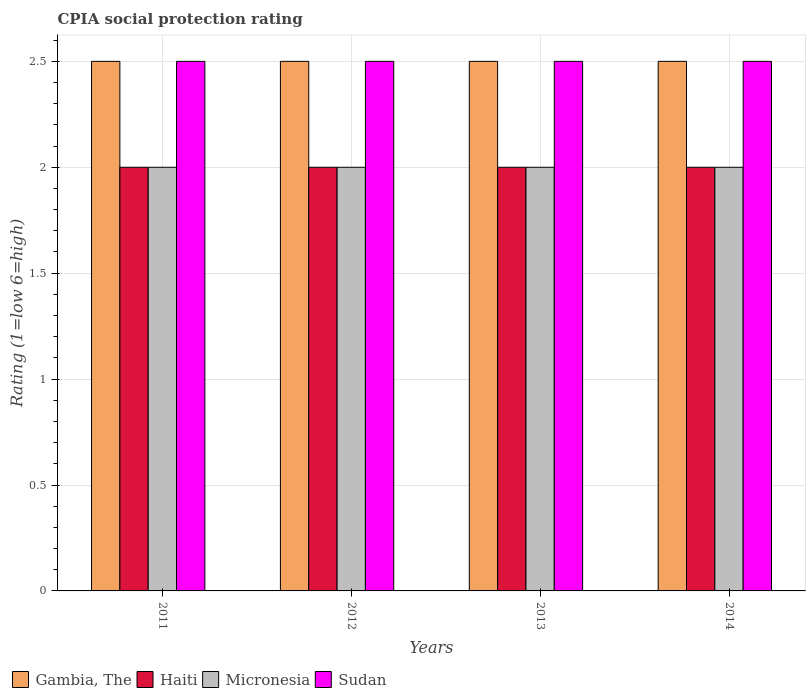How many groups of bars are there?
Provide a short and direct response. 4. Are the number of bars per tick equal to the number of legend labels?
Provide a succinct answer. Yes. How many bars are there on the 4th tick from the left?
Give a very brief answer. 4. How many bars are there on the 4th tick from the right?
Make the answer very short. 4. What is the label of the 2nd group of bars from the left?
Offer a very short reply. 2012. In how many cases, is the number of bars for a given year not equal to the number of legend labels?
Provide a succinct answer. 0. What is the CPIA rating in Sudan in 2012?
Ensure brevity in your answer.  2.5. Across all years, what is the maximum CPIA rating in Gambia, The?
Ensure brevity in your answer.  2.5. Across all years, what is the minimum CPIA rating in Micronesia?
Your answer should be very brief. 2. In which year was the CPIA rating in Sudan maximum?
Offer a very short reply. 2011. What is the total CPIA rating in Sudan in the graph?
Offer a very short reply. 10. What is the difference between the CPIA rating in Sudan in 2014 and the CPIA rating in Micronesia in 2013?
Provide a succinct answer. 0.5. What is the average CPIA rating in Gambia, The per year?
Provide a short and direct response. 2.5. In the year 2011, what is the difference between the CPIA rating in Sudan and CPIA rating in Haiti?
Ensure brevity in your answer.  0.5. Is the CPIA rating in Gambia, The in 2011 less than that in 2014?
Your response must be concise. No. In how many years, is the CPIA rating in Haiti greater than the average CPIA rating in Haiti taken over all years?
Ensure brevity in your answer.  0. Is the sum of the CPIA rating in Micronesia in 2011 and 2012 greater than the maximum CPIA rating in Haiti across all years?
Keep it short and to the point. Yes. Is it the case that in every year, the sum of the CPIA rating in Gambia, The and CPIA rating in Haiti is greater than the sum of CPIA rating in Sudan and CPIA rating in Micronesia?
Make the answer very short. Yes. What does the 3rd bar from the left in 2013 represents?
Your answer should be very brief. Micronesia. What does the 4th bar from the right in 2011 represents?
Your answer should be very brief. Gambia, The. Are the values on the major ticks of Y-axis written in scientific E-notation?
Your response must be concise. No. Does the graph contain any zero values?
Your answer should be compact. No. How are the legend labels stacked?
Keep it short and to the point. Horizontal. What is the title of the graph?
Your response must be concise. CPIA social protection rating. Does "Kuwait" appear as one of the legend labels in the graph?
Provide a short and direct response. No. What is the Rating (1=low 6=high) in Haiti in 2011?
Your response must be concise. 2. What is the Rating (1=low 6=high) in Gambia, The in 2012?
Keep it short and to the point. 2.5. What is the Rating (1=low 6=high) of Micronesia in 2012?
Your response must be concise. 2. What is the Rating (1=low 6=high) of Sudan in 2012?
Your response must be concise. 2.5. What is the Rating (1=low 6=high) in Gambia, The in 2013?
Provide a succinct answer. 2.5. What is the Rating (1=low 6=high) in Haiti in 2013?
Keep it short and to the point. 2. What is the Rating (1=low 6=high) in Micronesia in 2013?
Your answer should be very brief. 2. What is the Rating (1=low 6=high) in Sudan in 2013?
Make the answer very short. 2.5. What is the Rating (1=low 6=high) in Sudan in 2014?
Ensure brevity in your answer.  2.5. Across all years, what is the maximum Rating (1=low 6=high) in Gambia, The?
Provide a short and direct response. 2.5. Across all years, what is the maximum Rating (1=low 6=high) in Haiti?
Your answer should be compact. 2. Across all years, what is the maximum Rating (1=low 6=high) of Micronesia?
Provide a short and direct response. 2. Across all years, what is the maximum Rating (1=low 6=high) in Sudan?
Provide a short and direct response. 2.5. Across all years, what is the minimum Rating (1=low 6=high) in Haiti?
Offer a terse response. 2. Across all years, what is the minimum Rating (1=low 6=high) of Micronesia?
Provide a short and direct response. 2. Across all years, what is the minimum Rating (1=low 6=high) in Sudan?
Ensure brevity in your answer.  2.5. What is the total Rating (1=low 6=high) of Haiti in the graph?
Offer a terse response. 8. What is the total Rating (1=low 6=high) of Micronesia in the graph?
Make the answer very short. 8. What is the total Rating (1=low 6=high) in Sudan in the graph?
Offer a terse response. 10. What is the difference between the Rating (1=low 6=high) in Gambia, The in 2011 and that in 2012?
Offer a very short reply. 0. What is the difference between the Rating (1=low 6=high) of Haiti in 2011 and that in 2012?
Your answer should be very brief. 0. What is the difference between the Rating (1=low 6=high) in Micronesia in 2011 and that in 2012?
Give a very brief answer. 0. What is the difference between the Rating (1=low 6=high) in Haiti in 2011 and that in 2013?
Offer a very short reply. 0. What is the difference between the Rating (1=low 6=high) in Micronesia in 2011 and that in 2013?
Offer a very short reply. 0. What is the difference between the Rating (1=low 6=high) in Sudan in 2011 and that in 2013?
Offer a terse response. 0. What is the difference between the Rating (1=low 6=high) in Micronesia in 2011 and that in 2014?
Your answer should be very brief. 0. What is the difference between the Rating (1=low 6=high) of Sudan in 2011 and that in 2014?
Provide a succinct answer. 0. What is the difference between the Rating (1=low 6=high) of Haiti in 2012 and that in 2013?
Offer a very short reply. 0. What is the difference between the Rating (1=low 6=high) in Micronesia in 2012 and that in 2013?
Ensure brevity in your answer.  0. What is the difference between the Rating (1=low 6=high) of Sudan in 2012 and that in 2013?
Offer a very short reply. 0. What is the difference between the Rating (1=low 6=high) of Gambia, The in 2012 and that in 2014?
Your answer should be compact. 0. What is the difference between the Rating (1=low 6=high) in Micronesia in 2012 and that in 2014?
Provide a short and direct response. 0. What is the difference between the Rating (1=low 6=high) in Sudan in 2012 and that in 2014?
Keep it short and to the point. 0. What is the difference between the Rating (1=low 6=high) in Haiti in 2013 and that in 2014?
Your answer should be compact. 0. What is the difference between the Rating (1=low 6=high) in Sudan in 2013 and that in 2014?
Give a very brief answer. 0. What is the difference between the Rating (1=low 6=high) of Gambia, The in 2011 and the Rating (1=low 6=high) of Micronesia in 2012?
Offer a very short reply. 0.5. What is the difference between the Rating (1=low 6=high) of Haiti in 2011 and the Rating (1=low 6=high) of Micronesia in 2012?
Ensure brevity in your answer.  0. What is the difference between the Rating (1=low 6=high) in Gambia, The in 2011 and the Rating (1=low 6=high) in Sudan in 2013?
Your response must be concise. 0. What is the difference between the Rating (1=low 6=high) in Haiti in 2011 and the Rating (1=low 6=high) in Micronesia in 2013?
Provide a short and direct response. 0. What is the difference between the Rating (1=low 6=high) in Haiti in 2011 and the Rating (1=low 6=high) in Sudan in 2013?
Give a very brief answer. -0.5. What is the difference between the Rating (1=low 6=high) of Micronesia in 2011 and the Rating (1=low 6=high) of Sudan in 2013?
Offer a terse response. -0.5. What is the difference between the Rating (1=low 6=high) in Gambia, The in 2011 and the Rating (1=low 6=high) in Haiti in 2014?
Offer a terse response. 0.5. What is the difference between the Rating (1=low 6=high) of Gambia, The in 2011 and the Rating (1=low 6=high) of Micronesia in 2014?
Ensure brevity in your answer.  0.5. What is the difference between the Rating (1=low 6=high) in Gambia, The in 2011 and the Rating (1=low 6=high) in Sudan in 2014?
Keep it short and to the point. 0. What is the difference between the Rating (1=low 6=high) in Micronesia in 2011 and the Rating (1=low 6=high) in Sudan in 2014?
Provide a short and direct response. -0.5. What is the difference between the Rating (1=low 6=high) in Gambia, The in 2012 and the Rating (1=low 6=high) in Haiti in 2013?
Provide a succinct answer. 0.5. What is the difference between the Rating (1=low 6=high) in Gambia, The in 2012 and the Rating (1=low 6=high) in Micronesia in 2013?
Provide a short and direct response. 0.5. What is the difference between the Rating (1=low 6=high) of Gambia, The in 2012 and the Rating (1=low 6=high) of Sudan in 2013?
Offer a terse response. 0. What is the difference between the Rating (1=low 6=high) of Gambia, The in 2012 and the Rating (1=low 6=high) of Haiti in 2014?
Make the answer very short. 0.5. What is the difference between the Rating (1=low 6=high) of Gambia, The in 2012 and the Rating (1=low 6=high) of Micronesia in 2014?
Provide a short and direct response. 0.5. What is the difference between the Rating (1=low 6=high) in Micronesia in 2012 and the Rating (1=low 6=high) in Sudan in 2014?
Make the answer very short. -0.5. What is the difference between the Rating (1=low 6=high) of Gambia, The in 2013 and the Rating (1=low 6=high) of Micronesia in 2014?
Give a very brief answer. 0.5. What is the difference between the Rating (1=low 6=high) in Haiti in 2013 and the Rating (1=low 6=high) in Micronesia in 2014?
Provide a short and direct response. 0. What is the difference between the Rating (1=low 6=high) of Haiti in 2013 and the Rating (1=low 6=high) of Sudan in 2014?
Your answer should be compact. -0.5. What is the average Rating (1=low 6=high) of Micronesia per year?
Your response must be concise. 2. What is the average Rating (1=low 6=high) in Sudan per year?
Make the answer very short. 2.5. In the year 2011, what is the difference between the Rating (1=low 6=high) of Gambia, The and Rating (1=low 6=high) of Haiti?
Your answer should be very brief. 0.5. In the year 2011, what is the difference between the Rating (1=low 6=high) in Gambia, The and Rating (1=low 6=high) in Sudan?
Your answer should be very brief. 0. In the year 2011, what is the difference between the Rating (1=low 6=high) of Haiti and Rating (1=low 6=high) of Sudan?
Keep it short and to the point. -0.5. In the year 2012, what is the difference between the Rating (1=low 6=high) of Gambia, The and Rating (1=low 6=high) of Haiti?
Ensure brevity in your answer.  0.5. In the year 2012, what is the difference between the Rating (1=low 6=high) of Gambia, The and Rating (1=low 6=high) of Micronesia?
Offer a terse response. 0.5. In the year 2012, what is the difference between the Rating (1=low 6=high) of Haiti and Rating (1=low 6=high) of Micronesia?
Make the answer very short. 0. In the year 2013, what is the difference between the Rating (1=low 6=high) of Gambia, The and Rating (1=low 6=high) of Haiti?
Your response must be concise. 0.5. In the year 2013, what is the difference between the Rating (1=low 6=high) in Haiti and Rating (1=low 6=high) in Micronesia?
Keep it short and to the point. 0. In the year 2013, what is the difference between the Rating (1=low 6=high) of Micronesia and Rating (1=low 6=high) of Sudan?
Provide a short and direct response. -0.5. In the year 2014, what is the difference between the Rating (1=low 6=high) of Gambia, The and Rating (1=low 6=high) of Micronesia?
Provide a short and direct response. 0.5. In the year 2014, what is the difference between the Rating (1=low 6=high) of Gambia, The and Rating (1=low 6=high) of Sudan?
Your response must be concise. 0. In the year 2014, what is the difference between the Rating (1=low 6=high) in Haiti and Rating (1=low 6=high) in Sudan?
Provide a succinct answer. -0.5. What is the ratio of the Rating (1=low 6=high) of Haiti in 2011 to that in 2013?
Your answer should be compact. 1. What is the ratio of the Rating (1=low 6=high) of Micronesia in 2011 to that in 2013?
Your response must be concise. 1. What is the ratio of the Rating (1=low 6=high) of Sudan in 2011 to that in 2013?
Ensure brevity in your answer.  1. What is the ratio of the Rating (1=low 6=high) in Haiti in 2011 to that in 2014?
Keep it short and to the point. 1. What is the ratio of the Rating (1=low 6=high) in Micronesia in 2011 to that in 2014?
Ensure brevity in your answer.  1. What is the ratio of the Rating (1=low 6=high) in Sudan in 2011 to that in 2014?
Ensure brevity in your answer.  1. What is the ratio of the Rating (1=low 6=high) of Gambia, The in 2012 to that in 2013?
Make the answer very short. 1. What is the ratio of the Rating (1=low 6=high) of Haiti in 2012 to that in 2013?
Your response must be concise. 1. What is the ratio of the Rating (1=low 6=high) of Micronesia in 2012 to that in 2013?
Make the answer very short. 1. What is the ratio of the Rating (1=low 6=high) in Sudan in 2012 to that in 2013?
Keep it short and to the point. 1. What is the ratio of the Rating (1=low 6=high) of Haiti in 2012 to that in 2014?
Ensure brevity in your answer.  1. What is the ratio of the Rating (1=low 6=high) of Micronesia in 2012 to that in 2014?
Your answer should be very brief. 1. What is the ratio of the Rating (1=low 6=high) of Gambia, The in 2013 to that in 2014?
Ensure brevity in your answer.  1. What is the ratio of the Rating (1=low 6=high) of Haiti in 2013 to that in 2014?
Your answer should be very brief. 1. What is the ratio of the Rating (1=low 6=high) in Micronesia in 2013 to that in 2014?
Your answer should be compact. 1. What is the difference between the highest and the second highest Rating (1=low 6=high) of Gambia, The?
Your response must be concise. 0. What is the difference between the highest and the lowest Rating (1=low 6=high) of Haiti?
Offer a very short reply. 0. What is the difference between the highest and the lowest Rating (1=low 6=high) of Sudan?
Your response must be concise. 0. 